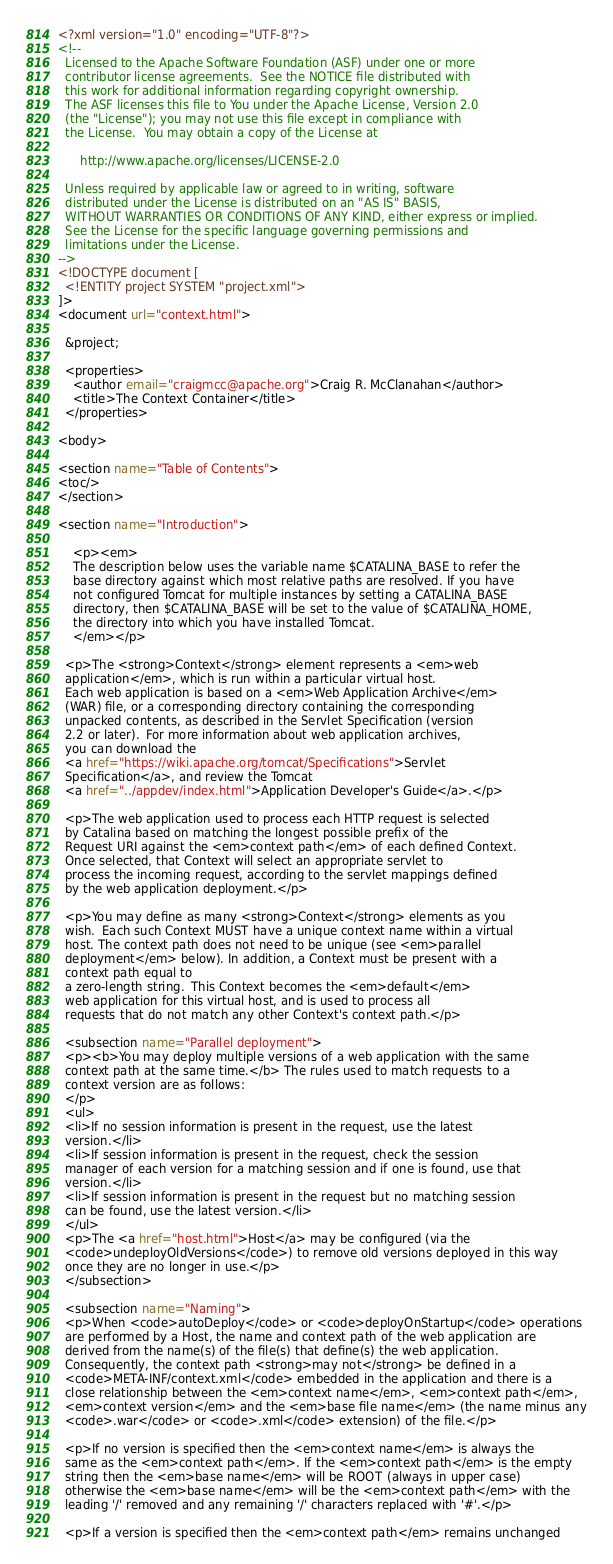<code> <loc_0><loc_0><loc_500><loc_500><_XML_><?xml version="1.0" encoding="UTF-8"?>
<!--
  Licensed to the Apache Software Foundation (ASF) under one or more
  contributor license agreements.  See the NOTICE file distributed with
  this work for additional information regarding copyright ownership.
  The ASF licenses this file to You under the Apache License, Version 2.0
  (the "License"); you may not use this file except in compliance with
  the License.  You may obtain a copy of the License at

      http://www.apache.org/licenses/LICENSE-2.0

  Unless required by applicable law or agreed to in writing, software
  distributed under the License is distributed on an "AS IS" BASIS,
  WITHOUT WARRANTIES OR CONDITIONS OF ANY KIND, either express or implied.
  See the License for the specific language governing permissions and
  limitations under the License.
-->
<!DOCTYPE document [
  <!ENTITY project SYSTEM "project.xml">
]>
<document url="context.html">

  &project;

  <properties>
    <author email="craigmcc@apache.org">Craig R. McClanahan</author>
    <title>The Context Container</title>
  </properties>

<body>

<section name="Table of Contents">
<toc/>
</section>

<section name="Introduction">

    <p><em>
    The description below uses the variable name $CATALINA_BASE to refer the
    base directory against which most relative paths are resolved. If you have
    not configured Tomcat for multiple instances by setting a CATALINA_BASE
    directory, then $CATALINA_BASE will be set to the value of $CATALINA_HOME,
    the directory into which you have installed Tomcat.
    </em></p>

  <p>The <strong>Context</strong> element represents a <em>web
  application</em>, which is run within a particular virtual host.
  Each web application is based on a <em>Web Application Archive</em>
  (WAR) file, or a corresponding directory containing the corresponding
  unpacked contents, as described in the Servlet Specification (version
  2.2 or later).  For more information about web application archives,
  you can download the
  <a href="https://wiki.apache.org/tomcat/Specifications">Servlet
  Specification</a>, and review the Tomcat
  <a href="../appdev/index.html">Application Developer's Guide</a>.</p>

  <p>The web application used to process each HTTP request is selected
  by Catalina based on matching the longest possible prefix of the
  Request URI against the <em>context path</em> of each defined Context.
  Once selected, that Context will select an appropriate servlet to
  process the incoming request, according to the servlet mappings defined
  by the web application deployment.</p>

  <p>You may define as many <strong>Context</strong> elements as you
  wish.  Each such Context MUST have a unique context name within a virtual
  host. The context path does not need to be unique (see <em>parallel
  deployment</em> below). In addition, a Context must be present with a
  context path equal to
  a zero-length string.  This Context becomes the <em>default</em>
  web application for this virtual host, and is used to process all
  requests that do not match any other Context's context path.</p>

  <subsection name="Parallel deployment">
  <p><b>You may deploy multiple versions of a web application with the same
  context path at the same time.</b> The rules used to match requests to a
  context version are as follows:
  </p>
  <ul>
  <li>If no session information is present in the request, use the latest
  version.</li>
  <li>If session information is present in the request, check the session
  manager of each version for a matching session and if one is found, use that
  version.</li>
  <li>If session information is present in the request but no matching session
  can be found, use the latest version.</li>
  </ul>
  <p>The <a href="host.html">Host</a> may be configured (via the
  <code>undeployOldVersions</code>) to remove old versions deployed in this way
  once they are no longer in use.</p>
  </subsection>

  <subsection name="Naming">
  <p>When <code>autoDeploy</code> or <code>deployOnStartup</code> operations
  are performed by a Host, the name and context path of the web application are
  derived from the name(s) of the file(s) that define(s) the web application.
  Consequently, the context path <strong>may not</strong> be defined in a
  <code>META-INF/context.xml</code> embedded in the application and there is a
  close relationship between the <em>context name</em>, <em>context path</em>,
  <em>context version</em> and the <em>base file name</em> (the name minus any
  <code>.war</code> or <code>.xml</code> extension) of the file.</p>

  <p>If no version is specified then the <em>context name</em> is always the
  same as the <em>context path</em>. If the <em>context path</em> is the empty
  string then the <em>base name</em> will be ROOT (always in upper case)
  otherwise the <em>base name</em> will be the <em>context path</em> with the
  leading '/' removed and any remaining '/' characters replaced with '#'.</p>

  <p>If a version is specified then the <em>context path</em> remains unchanged</code> 